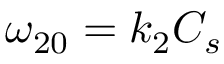<formula> <loc_0><loc_0><loc_500><loc_500>\omega _ { 2 0 } = k _ { 2 } C _ { s }</formula> 